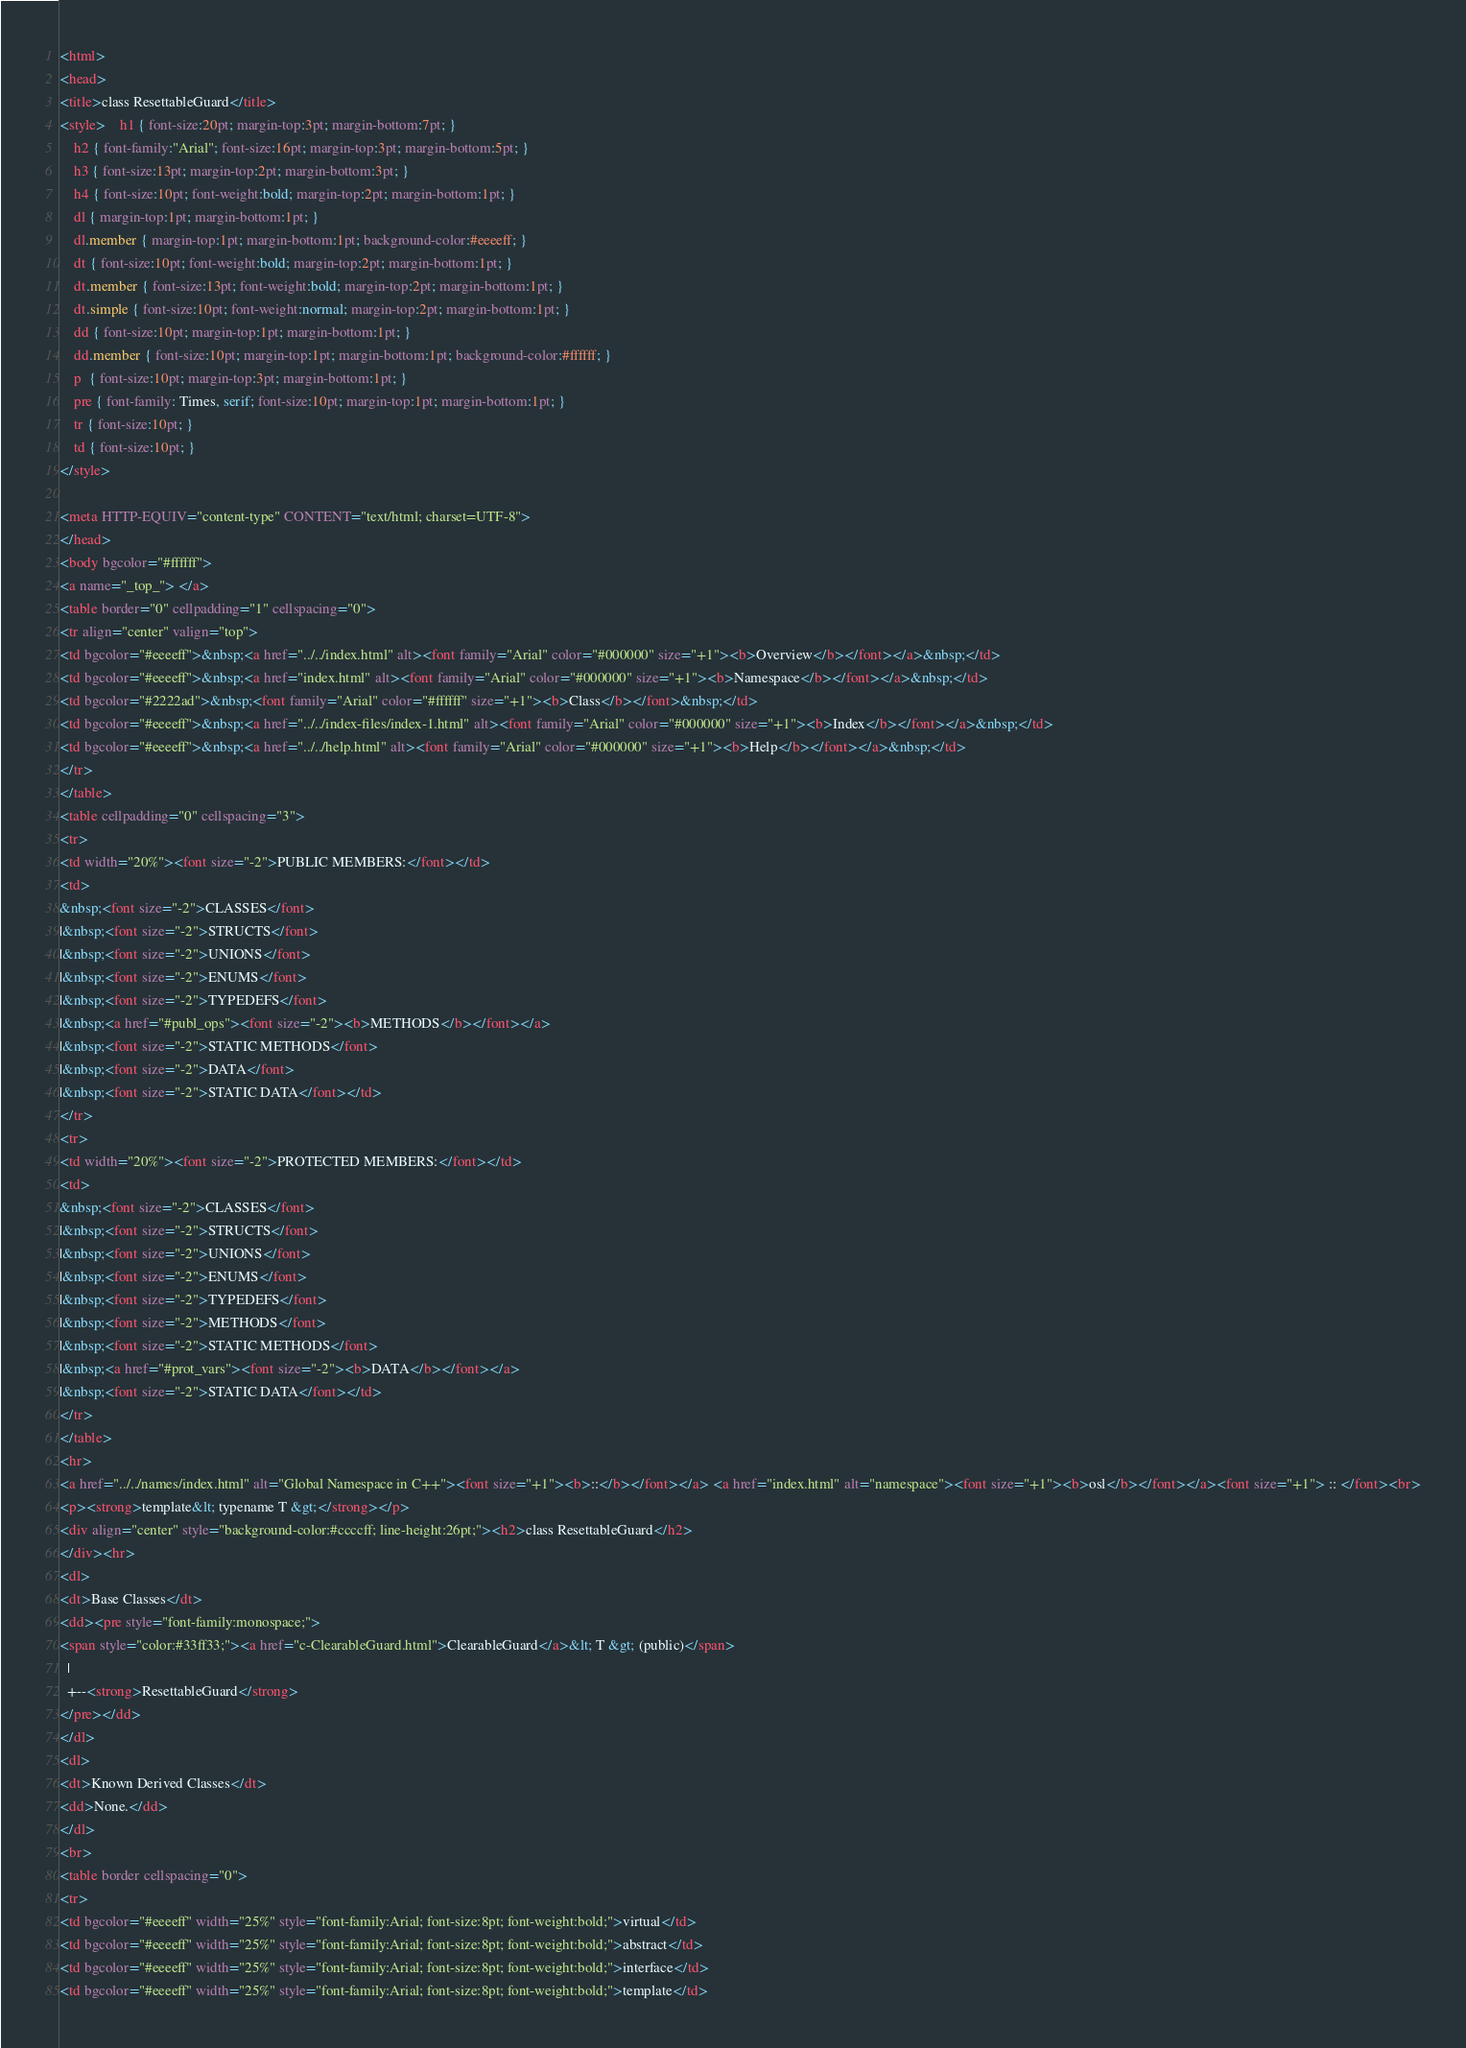<code> <loc_0><loc_0><loc_500><loc_500><_HTML_><html>
<head>
<title>class ResettableGuard</title>
<style>	h1 { font-size:20pt; margin-top:3pt; margin-bottom:7pt; }
	h2 { font-family:"Arial"; font-size:16pt; margin-top:3pt; margin-bottom:5pt; }
	h3 { font-size:13pt; margin-top:2pt; margin-bottom:3pt; }
	h4 { font-size:10pt; font-weight:bold; margin-top:2pt; margin-bottom:1pt; }
	dl { margin-top:1pt; margin-bottom:1pt; }
	dl.member { margin-top:1pt; margin-bottom:1pt; background-color:#eeeeff; }
	dt { font-size:10pt; font-weight:bold; margin-top:2pt; margin-bottom:1pt; }
	dt.member { font-size:13pt; font-weight:bold; margin-top:2pt; margin-bottom:1pt; }
	dt.simple { font-size:10pt; font-weight:normal; margin-top:2pt; margin-bottom:1pt; }
	dd { font-size:10pt; margin-top:1pt; margin-bottom:1pt; }
	dd.member { font-size:10pt; margin-top:1pt; margin-bottom:1pt; background-color:#ffffff; }
	p  { font-size:10pt; margin-top:3pt; margin-bottom:1pt; }
	pre { font-family: Times, serif; font-size:10pt; margin-top:1pt; margin-bottom:1pt; }
	tr { font-size:10pt; }
	td { font-size:10pt; }
</style>

<meta HTTP-EQUIV="content-type" CONTENT="text/html; charset=UTF-8">
</head>
<body bgcolor="#ffffff">
<a name="_top_"> </a>
<table border="0" cellpadding="1" cellspacing="0">
<tr align="center" valign="top">
<td bgcolor="#eeeeff">&nbsp;<a href="../../index.html" alt><font family="Arial" color="#000000" size="+1"><b>Overview</b></font></a>&nbsp;</td>
<td bgcolor="#eeeeff">&nbsp;<a href="index.html" alt><font family="Arial" color="#000000" size="+1"><b>Namespace</b></font></a>&nbsp;</td>
<td bgcolor="#2222ad">&nbsp;<font family="Arial" color="#ffffff" size="+1"><b>Class</b></font>&nbsp;</td>
<td bgcolor="#eeeeff">&nbsp;<a href="../../index-files/index-1.html" alt><font family="Arial" color="#000000" size="+1"><b>Index</b></font></a>&nbsp;</td>
<td bgcolor="#eeeeff">&nbsp;<a href="../../help.html" alt><font family="Arial" color="#000000" size="+1"><b>Help</b></font></a>&nbsp;</td>
</tr>
</table>
<table cellpadding="0" cellspacing="3">
<tr>
<td width="20%"><font size="-2">PUBLIC MEMBERS:</font></td>
<td>
&nbsp;<font size="-2">CLASSES</font>
|&nbsp;<font size="-2">STRUCTS</font>
|&nbsp;<font size="-2">UNIONS</font>
|&nbsp;<font size="-2">ENUMS</font>
|&nbsp;<font size="-2">TYPEDEFS</font>
|&nbsp;<a href="#publ_ops"><font size="-2"><b>METHODS</b></font></a>
|&nbsp;<font size="-2">STATIC METHODS</font>
|&nbsp;<font size="-2">DATA</font>
|&nbsp;<font size="-2">STATIC DATA</font></td>
</tr>
<tr>
<td width="20%"><font size="-2">PROTECTED MEMBERS:</font></td>
<td>
&nbsp;<font size="-2">CLASSES</font>
|&nbsp;<font size="-2">STRUCTS</font>
|&nbsp;<font size="-2">UNIONS</font>
|&nbsp;<font size="-2">ENUMS</font>
|&nbsp;<font size="-2">TYPEDEFS</font>
|&nbsp;<font size="-2">METHODS</font>
|&nbsp;<font size="-2">STATIC METHODS</font>
|&nbsp;<a href="#prot_vars"><font size="-2"><b>DATA</b></font></a>
|&nbsp;<font size="-2">STATIC DATA</font></td>
</tr>
</table>
<hr>
<a href="../../names/index.html" alt="Global Namespace in C++"><font size="+1"><b>::</b></font></a> <a href="index.html" alt="namespace"><font size="+1"><b>osl</b></font></a><font size="+1"> :: </font><br>
<p><strong>template&lt; typename T &gt;</strong></p>
<div align="center" style="background-color:#ccccff; line-height:26pt;"><h2>class ResettableGuard</h2>
</div><hr>
<dl>
<dt>Base Classes</dt>
<dd><pre style="font-family:monospace;">
<span style="color:#33ff33;"><a href="c-ClearableGuard.html">ClearableGuard</a>&lt; T &gt; (public)</span>
  |  
  +--<strong>ResettableGuard</strong>
</pre></dd>
</dl>
<dl>
<dt>Known Derived Classes</dt>
<dd>None.</dd>
</dl>
<br>
<table border cellspacing="0">
<tr>
<td bgcolor="#eeeeff" width="25%" style="font-family:Arial; font-size:8pt; font-weight:bold;">virtual</td>
<td bgcolor="#eeeeff" width="25%" style="font-family:Arial; font-size:8pt; font-weight:bold;">abstract</td>
<td bgcolor="#eeeeff" width="25%" style="font-family:Arial; font-size:8pt; font-weight:bold;">interface</td>
<td bgcolor="#eeeeff" width="25%" style="font-family:Arial; font-size:8pt; font-weight:bold;">template</td></code> 